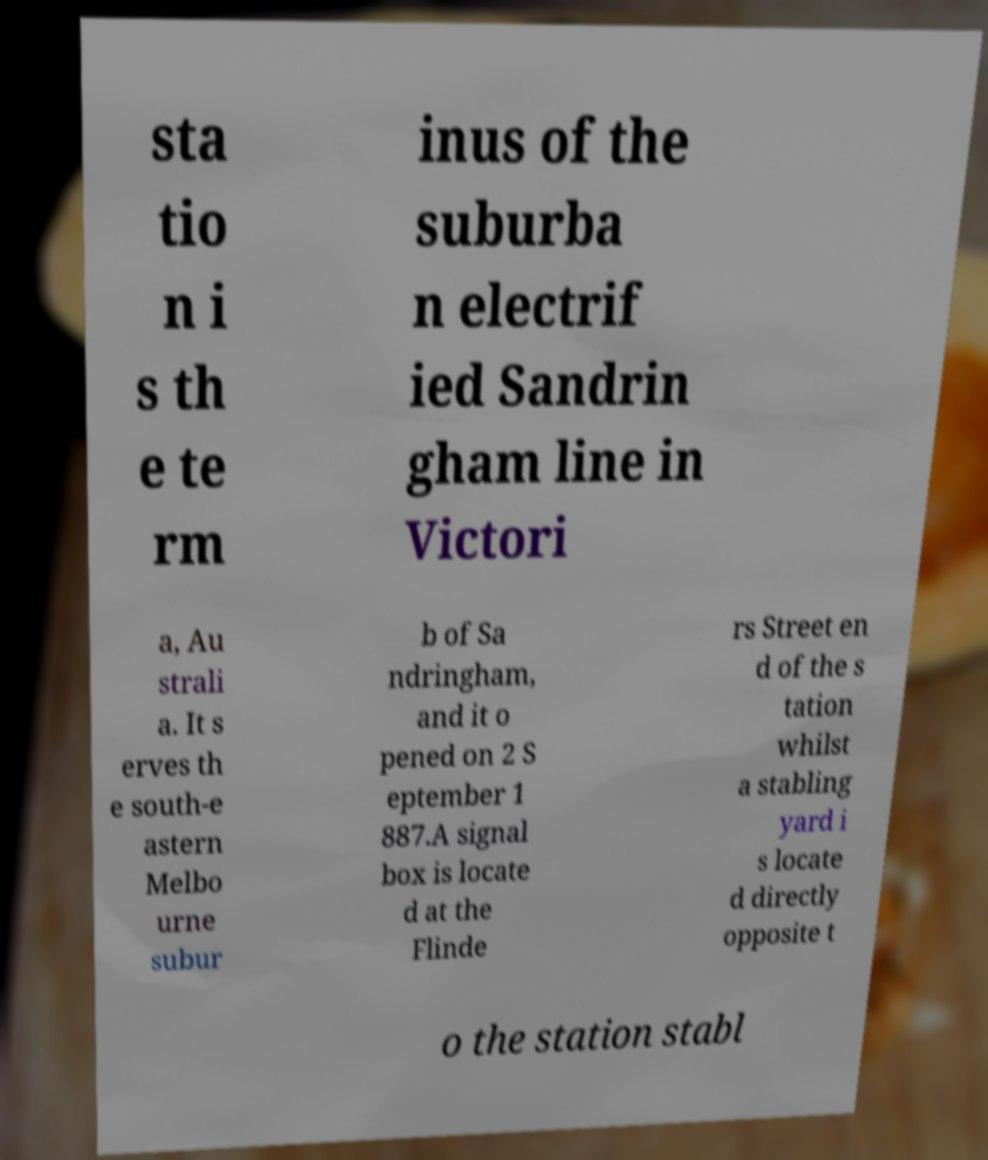Could you extract and type out the text from this image? sta tio n i s th e te rm inus of the suburba n electrif ied Sandrin gham line in Victori a, Au strali a. It s erves th e south-e astern Melbo urne subur b of Sa ndringham, and it o pened on 2 S eptember 1 887.A signal box is locate d at the Flinde rs Street en d of the s tation whilst a stabling yard i s locate d directly opposite t o the station stabl 